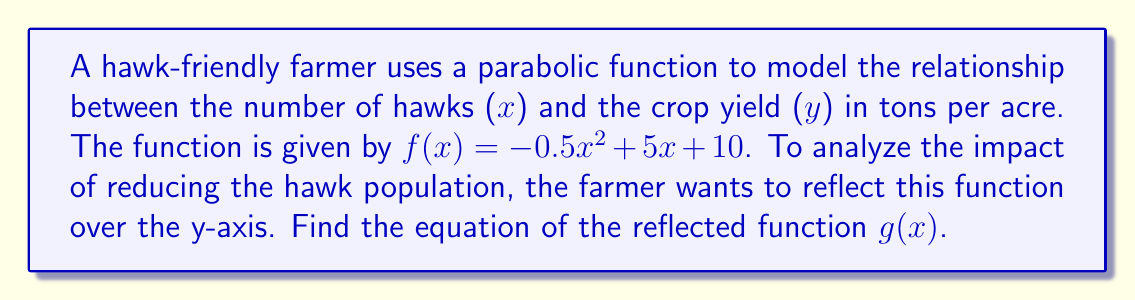Can you answer this question? To reflect a function over the y-axis, we replace every x with -x in the original function. Let's do this step-by-step:

1. Start with the original function:
   $f(x) = -0.5x^2 + 5x + 10$

2. Replace every x with -x:
   $g(x) = -0.5(-x)^2 + 5(-x) + 10$

3. Simplify the squared term:
   $g(x) = -0.5x^2 - 5x + 10$

4. The final reflected function is:
   $g(x) = -0.5x^2 - 5x + 10$

Note that the coefficient of $x^2$ remains the same, the coefficient of x changes sign, and the constant term stays the same. This reflection shows how the crop yield would change if the number of hawks were reduced instead of increased.
Answer: $g(x) = -0.5x^2 - 5x + 10$ 